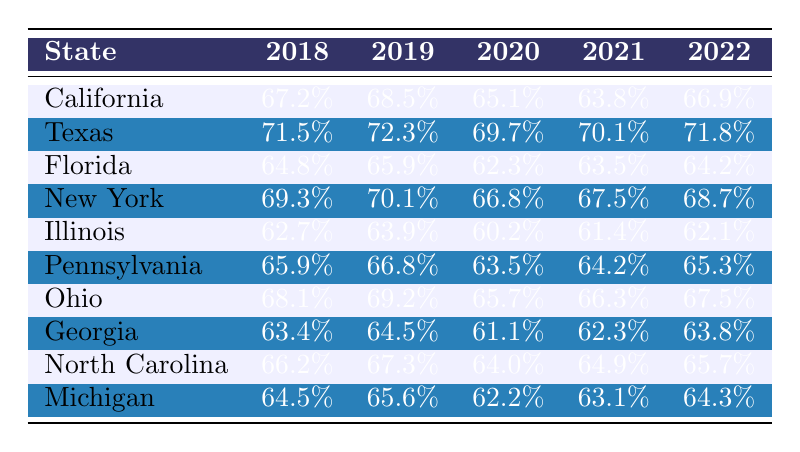What was the conviction rate for Texas in 2020? The conviction rate for Texas in 2020 is directly provided in the table, where it states "69.7%" in the relevant cell for that year.
Answer: 69.7% Which state had the highest conviction rate in 2019? From the table, we can identify the conviction rates for 2019: California (68.5%), Texas (72.3%), Florida (65.9%), New York (70.1%), Illinois (63.9%), Pennsylvania (66.8%), Ohio (69.2%), Georgia (64.5%), North Carolina (67.3%), and Michigan (65.6%). Observing all these values, Texas has the highest at 72.3%.
Answer: Texas What is the average conviction rate for California over the past five years? To calculate the average, we sum the conviction rates from 2018 to 2022: 67.2% + 68.5% + 65.1% + 63.8% + 66.9% = 331.5%. To find the average, we divide by the number of years (5): 331.5% / 5 = 66.3%.
Answer: 66.3% Did Florida have a higher conviction rate than Illinois in 2021? In the table, Florida's conviction rate for 2021 is 63.5% and Illinois’s is 61.4%. Since 63.5% is greater than 61.4%, Florida did indeed have a higher conviction rate.
Answer: Yes 